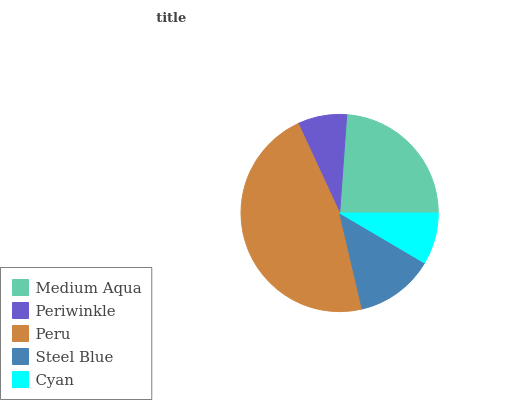Is Periwinkle the minimum?
Answer yes or no. Yes. Is Peru the maximum?
Answer yes or no. Yes. Is Peru the minimum?
Answer yes or no. No. Is Periwinkle the maximum?
Answer yes or no. No. Is Peru greater than Periwinkle?
Answer yes or no. Yes. Is Periwinkle less than Peru?
Answer yes or no. Yes. Is Periwinkle greater than Peru?
Answer yes or no. No. Is Peru less than Periwinkle?
Answer yes or no. No. Is Steel Blue the high median?
Answer yes or no. Yes. Is Steel Blue the low median?
Answer yes or no. Yes. Is Cyan the high median?
Answer yes or no. No. Is Periwinkle the low median?
Answer yes or no. No. 